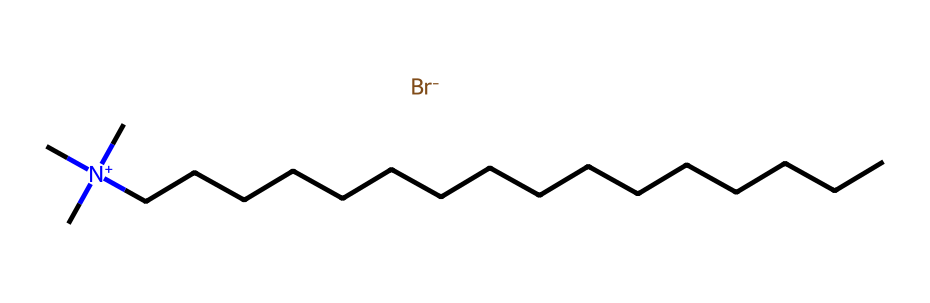What is the molecular formula of cetrimonium bromide? To find the molecular formula, we need to identify the elements present in the structure from the SMILES representation. The presence of carbon atoms in the long alkyl chain and the nitrogen, as well as the bromine ion, points to the formula being C16H34BrN.
Answer: C16H34BrN How many carbon atoms are in cetrimonium bromide? Counting the 'C' present in the alkyl chain from the SMILES representation reveals there are 16 carbon atoms linked to one nitrogen atom.
Answer: 16 What type of surfactant is cetrimonium bromide? The presence of a positively charged nitrogen atom indicates that this surfactant is cationic, as cationic surfactants are characterized by a positively charged head group.
Answer: cationic What charge does cetrimonium bromide carry? The nitrogen in the structure is positively charged due to the attached quaternary ammonium ions, while bromine carries a negative charge as a counter ion, confirming that the overall charge present is positive.
Answer: positive What property of cetrimonium bromide allows it to condition hair? Cationic surfactants like cetrimonium bromide have a tendency to bind to negatively charged surfaces, such as hair strands, enhancing moisture retention and reducing frizz, which are key conditioning properties.
Answer: moisture retention How many hydrogen atoms are present in the cetrimonium bromide structure? From the SMILES representation, we can calculate the number of hydrogen atoms. Each carbon in the chain generally has two hydrogen atoms (except at the ends which have three), and considering the ionic nature, the total adds up to 34, making the count accurate.
Answer: 34 What functional group is indicated in the structure of cetrimonium bromide? The presence of the quaternary nitrogen group is a defining feature of cationic surfactants. This nitrogen atom signifies that cetrimonium bromide belongs to a class of amines known for their surfactant properties.
Answer: quaternary amine 